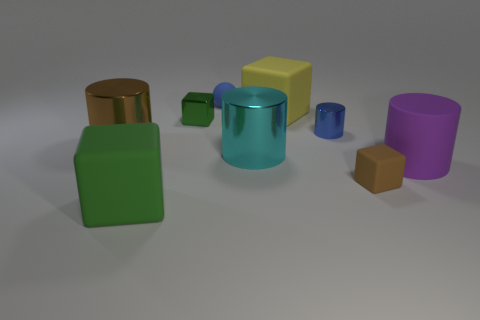Subtract all balls. How many objects are left? 8 Add 4 large blue rubber spheres. How many large blue rubber spheres exist? 4 Subtract 1 brown cylinders. How many objects are left? 8 Subtract all large cylinders. Subtract all big shiny cylinders. How many objects are left? 4 Add 6 shiny cylinders. How many shiny cylinders are left? 9 